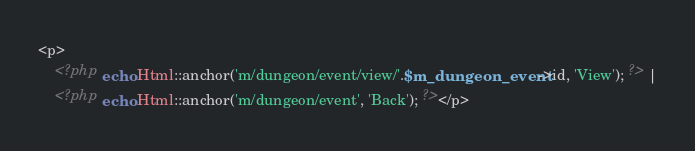Convert code to text. <code><loc_0><loc_0><loc_500><loc_500><_PHP_><p>
	<?php echo Html::anchor('m/dungeon/event/view/'.$m_dungeon_event->id, 'View'); ?> |
	<?php echo Html::anchor('m/dungeon/event', 'Back'); ?></p>
</code> 